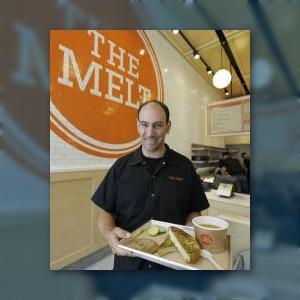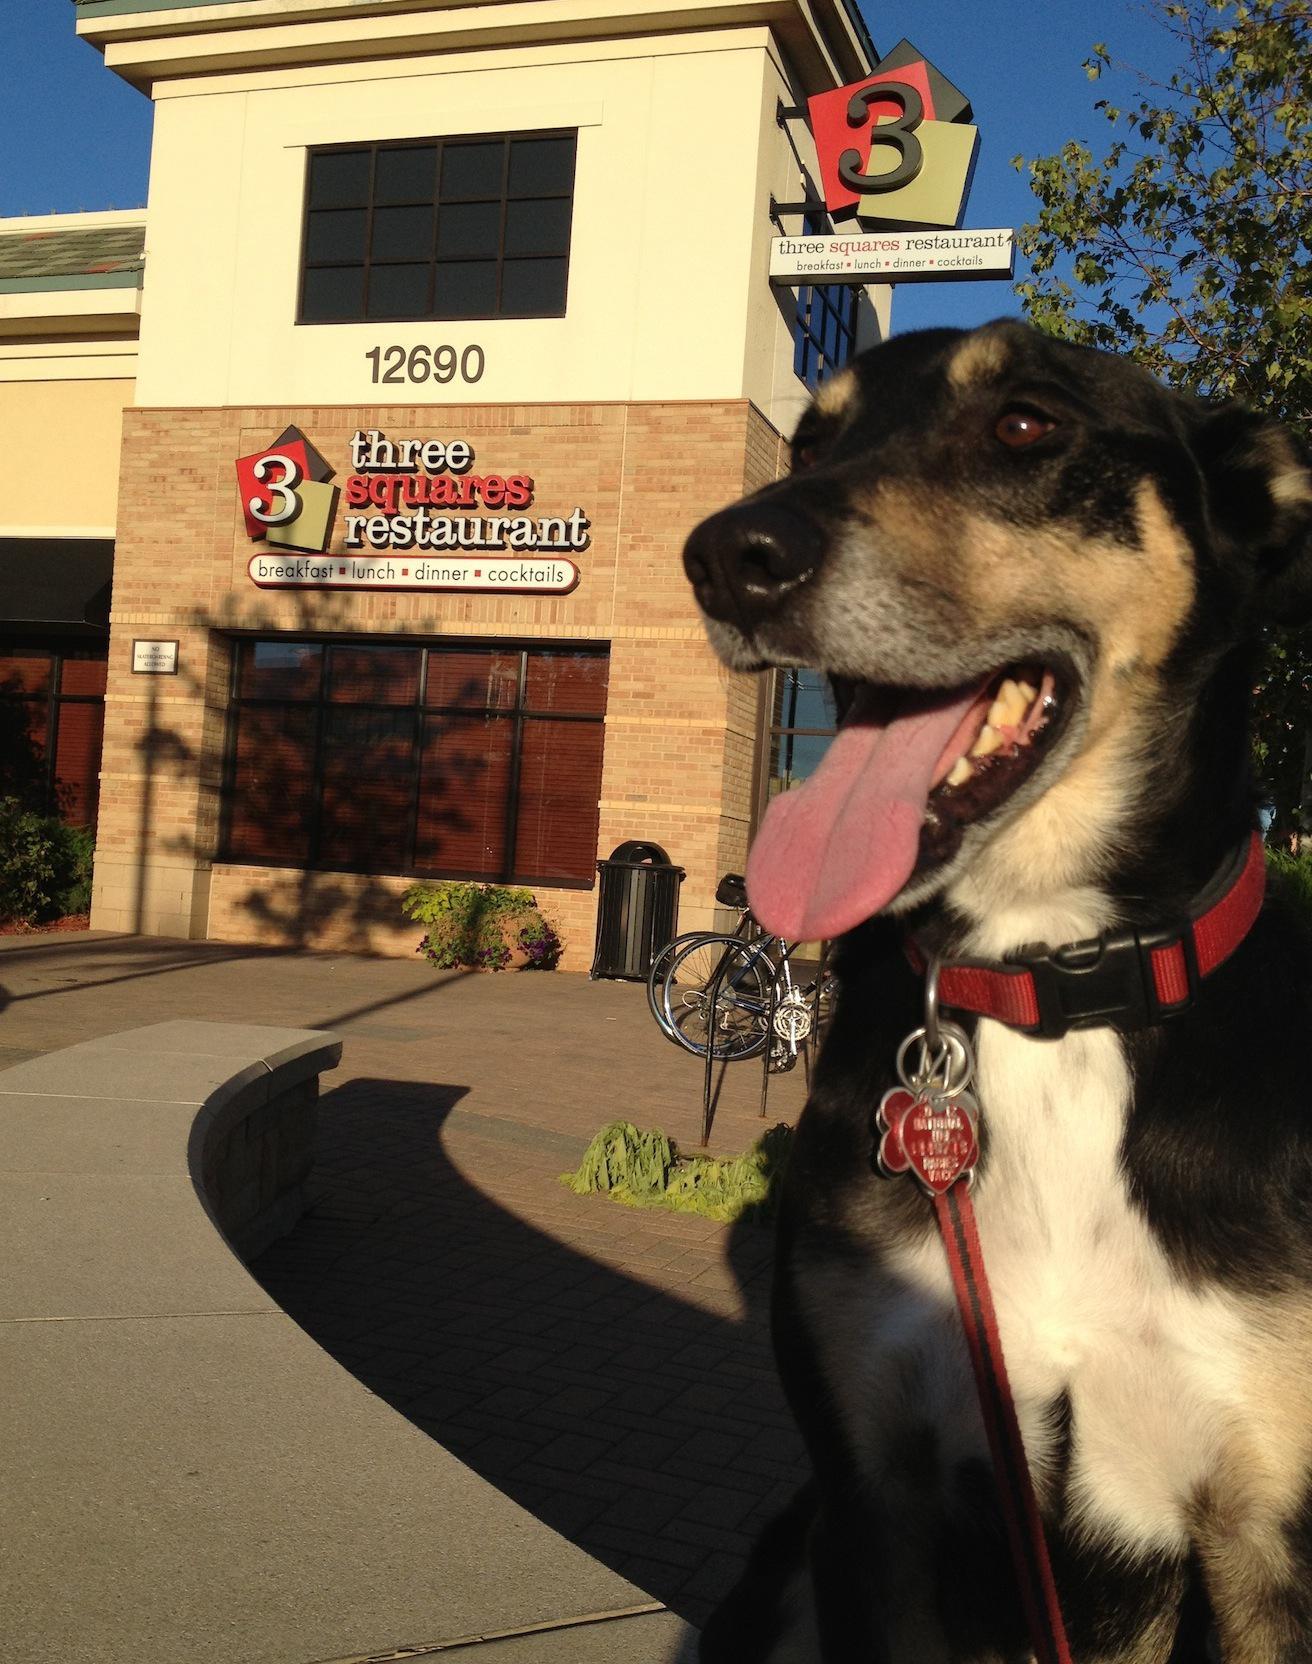The first image is the image on the left, the second image is the image on the right. Given the left and right images, does the statement "There are customers sitting." hold true? Answer yes or no. No. The first image is the image on the left, the second image is the image on the right. Analyze the images presented: Is the assertion "The left image includes a man wearing black on top standing in front of a counter, and a white tray containing food." valid? Answer yes or no. Yes. 